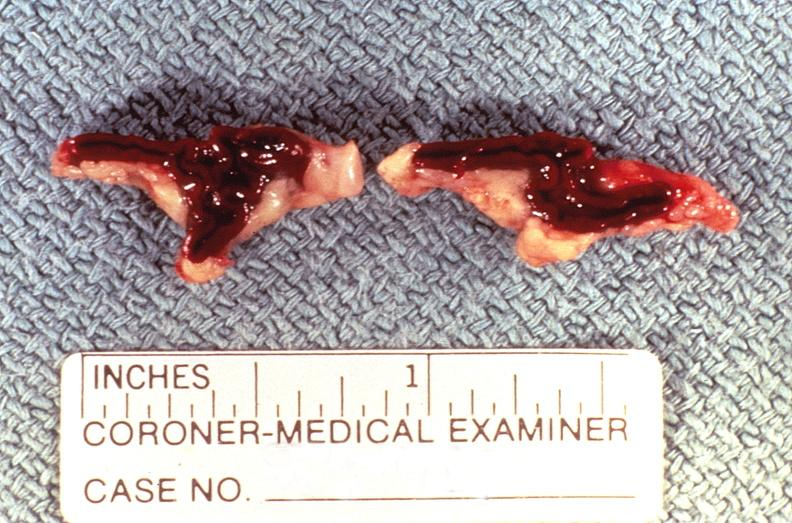does pituitary show adrenal gland, severe hemorrhage waterhouse-friderichsen syndrome?
Answer the question using a single word or phrase. No 